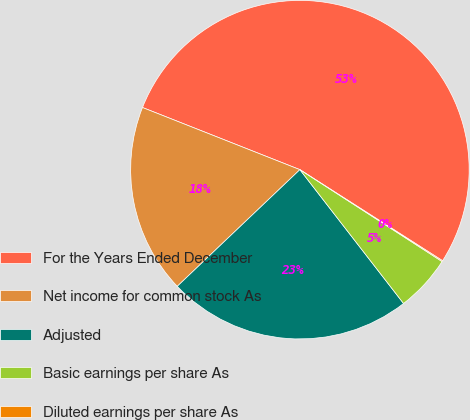Convert chart. <chart><loc_0><loc_0><loc_500><loc_500><pie_chart><fcel>For the Years Ended December<fcel>Net income for common stock As<fcel>Adjusted<fcel>Basic earnings per share As<fcel>Diluted earnings per share As<nl><fcel>53.06%<fcel>18.09%<fcel>23.39%<fcel>5.38%<fcel>0.09%<nl></chart> 